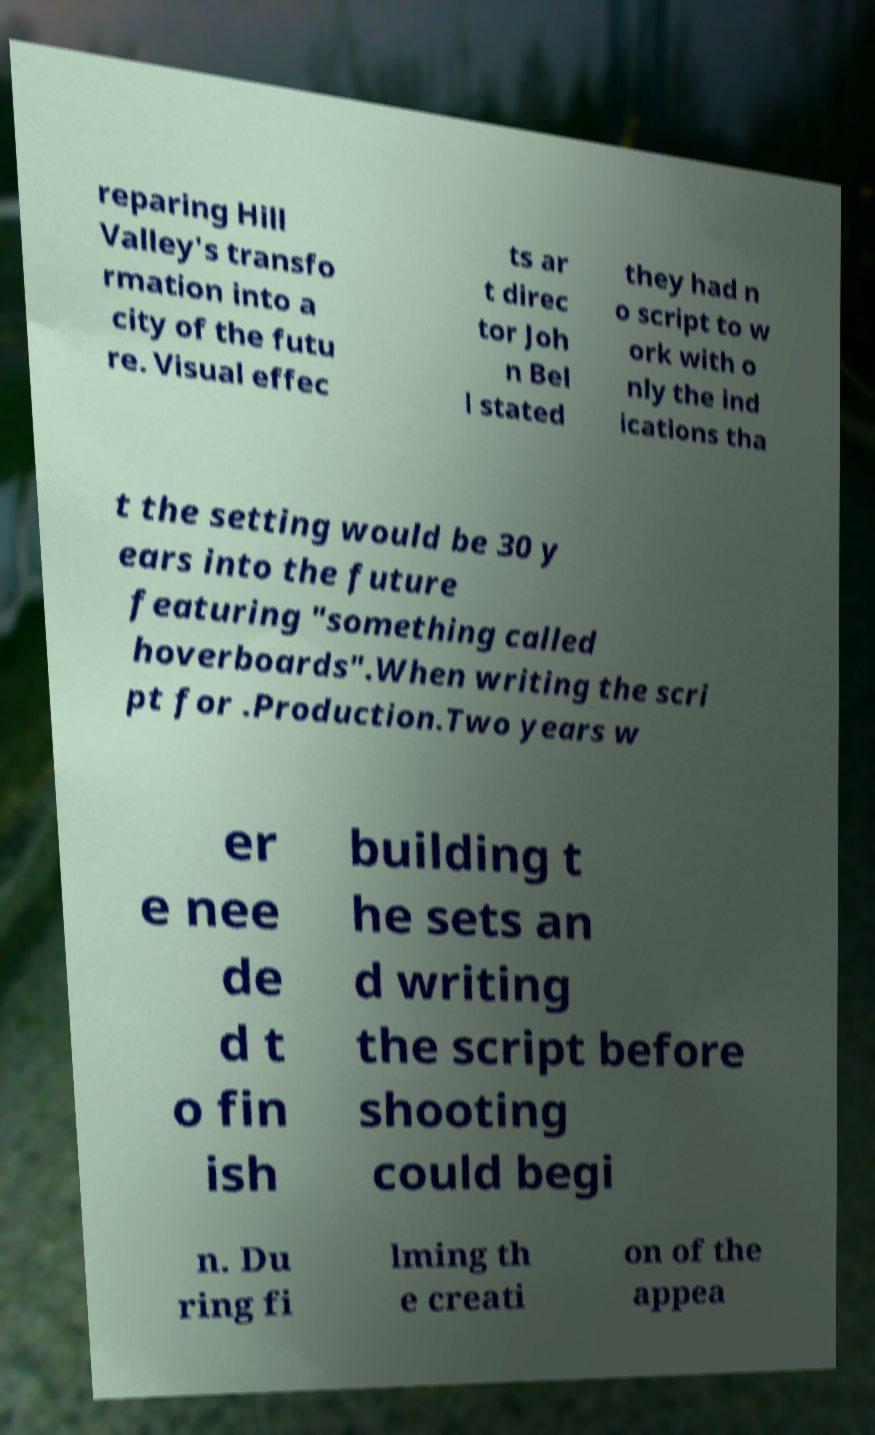There's text embedded in this image that I need extracted. Can you transcribe it verbatim? reparing Hill Valley's transfo rmation into a city of the futu re. Visual effec ts ar t direc tor Joh n Bel l stated they had n o script to w ork with o nly the ind ications tha t the setting would be 30 y ears into the future featuring "something called hoverboards".When writing the scri pt for .Production.Two years w er e nee de d t o fin ish building t he sets an d writing the script before shooting could begi n. Du ring fi lming th e creati on of the appea 